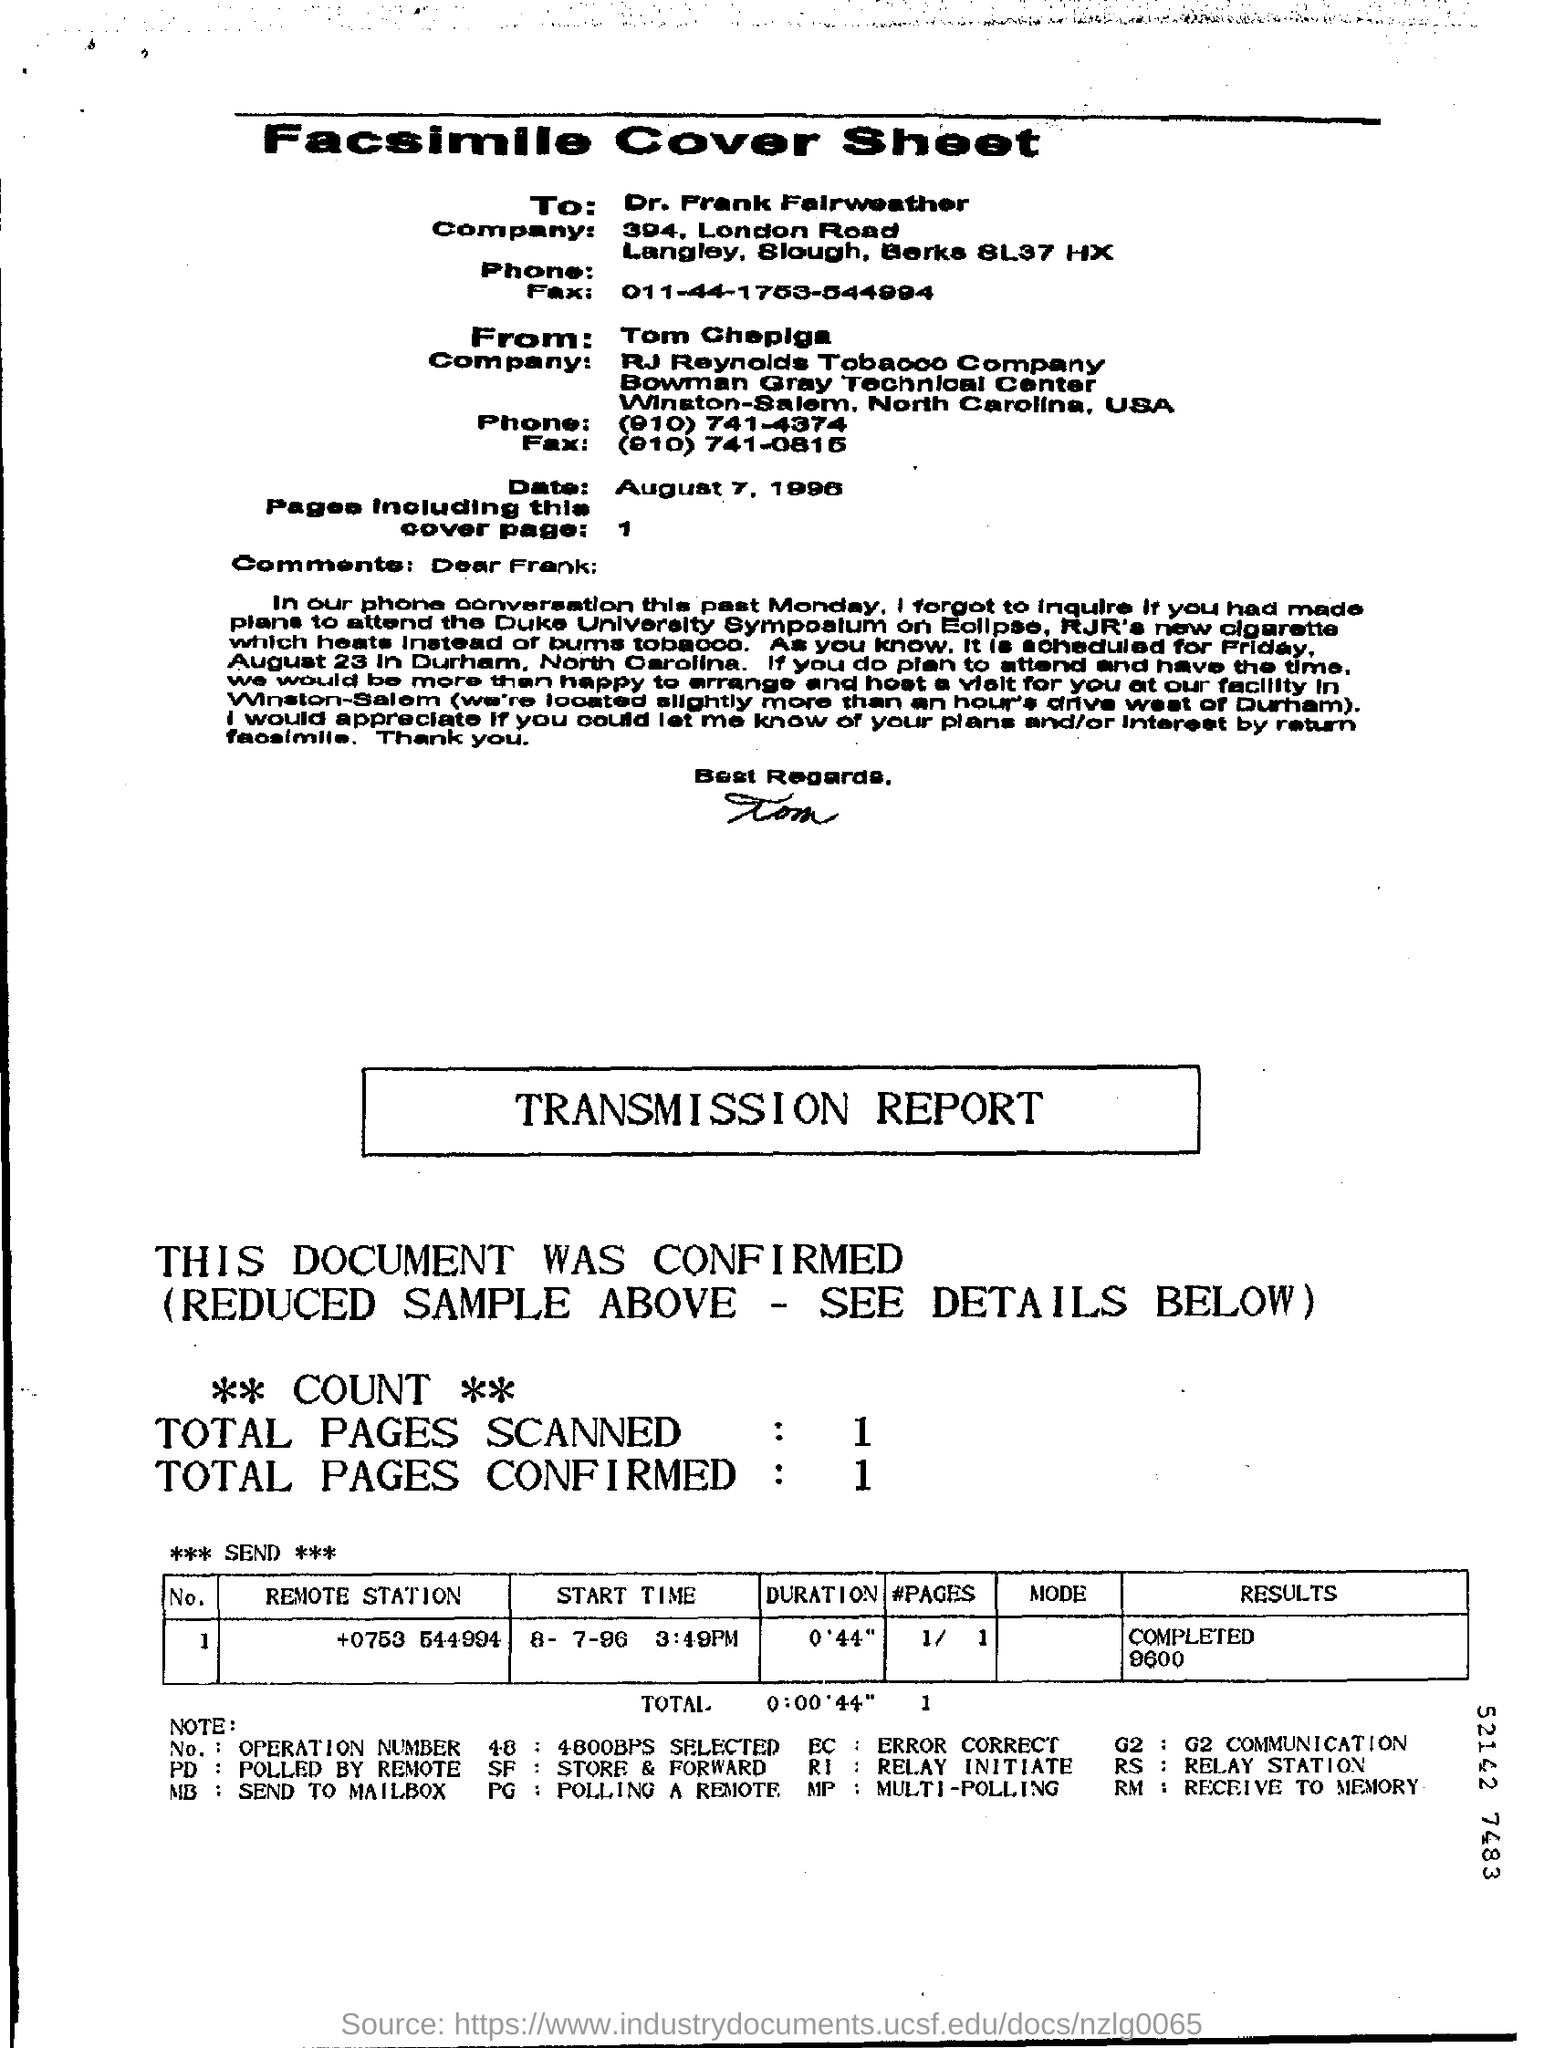Who is this Fax addressed from?
Your response must be concise. Tom Chepiga. To Whom is this Fax addressed to?
Your answer should be very brief. Dr. frank Fairweather. What is the Date?
Provide a succinct answer. August 7, 1996. What is the "Duration" for "Remote station" "+0753 544994"?
Give a very brief answer. 0'44". What is the "Results" for "Remote station" "+0753 544994"?
Keep it short and to the point. COMPLETED 9600. What are the Total Pages Scanned?
Your answer should be compact. 1. What are the Total Pages Confirmed?
Offer a very short reply. 1. 